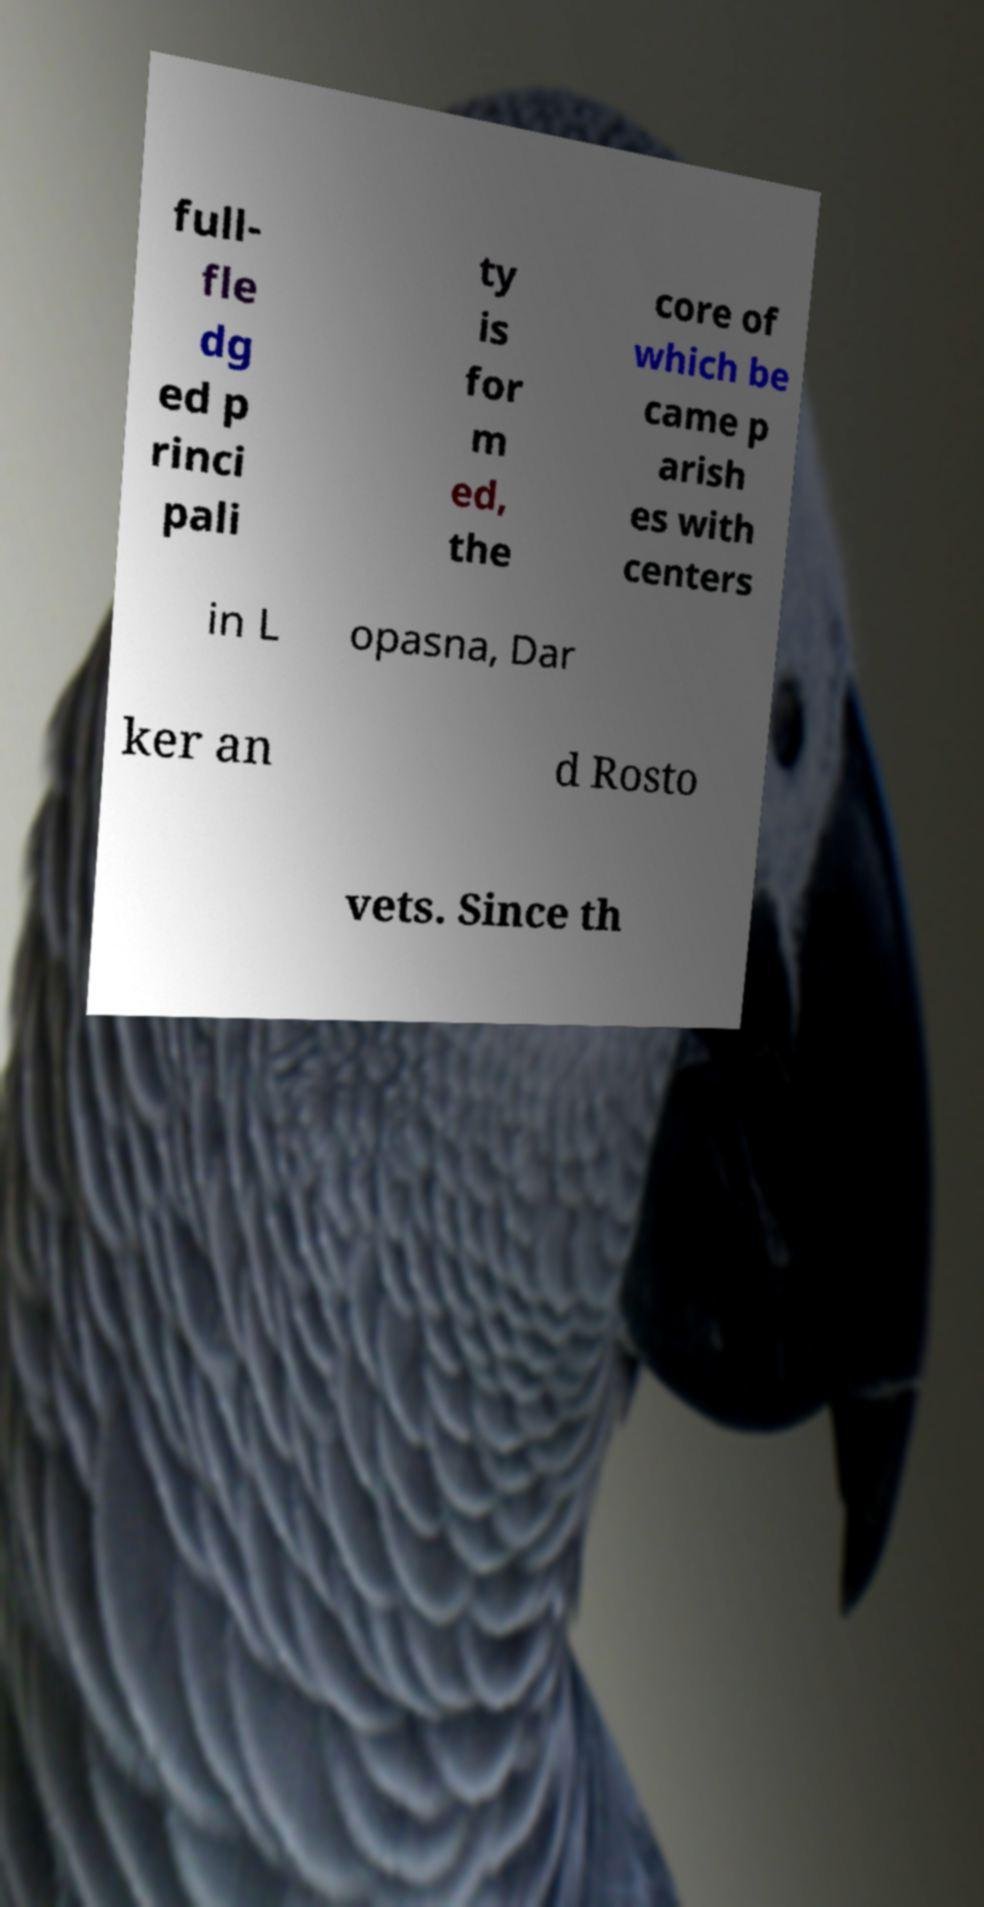Could you extract and type out the text from this image? full- fle dg ed p rinci pali ty is for m ed, the core of which be came p arish es with centers in L opasna, Dar ker an d Rosto vets. Since th 